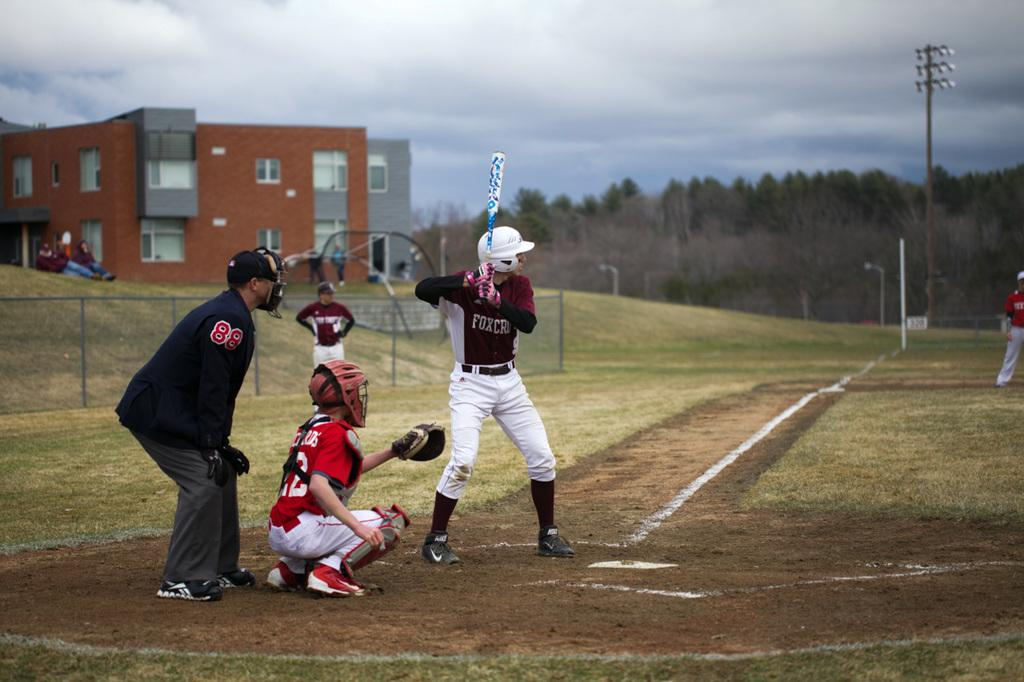Provide a one-sentence caption for the provided image. A baseball player up to bat at a baseball game with a burgundy and white shirt on with the word FOX on the front. 